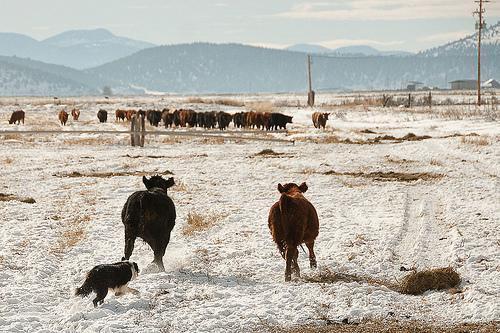How many dogs are in the picture?
Give a very brief answer. 1. 